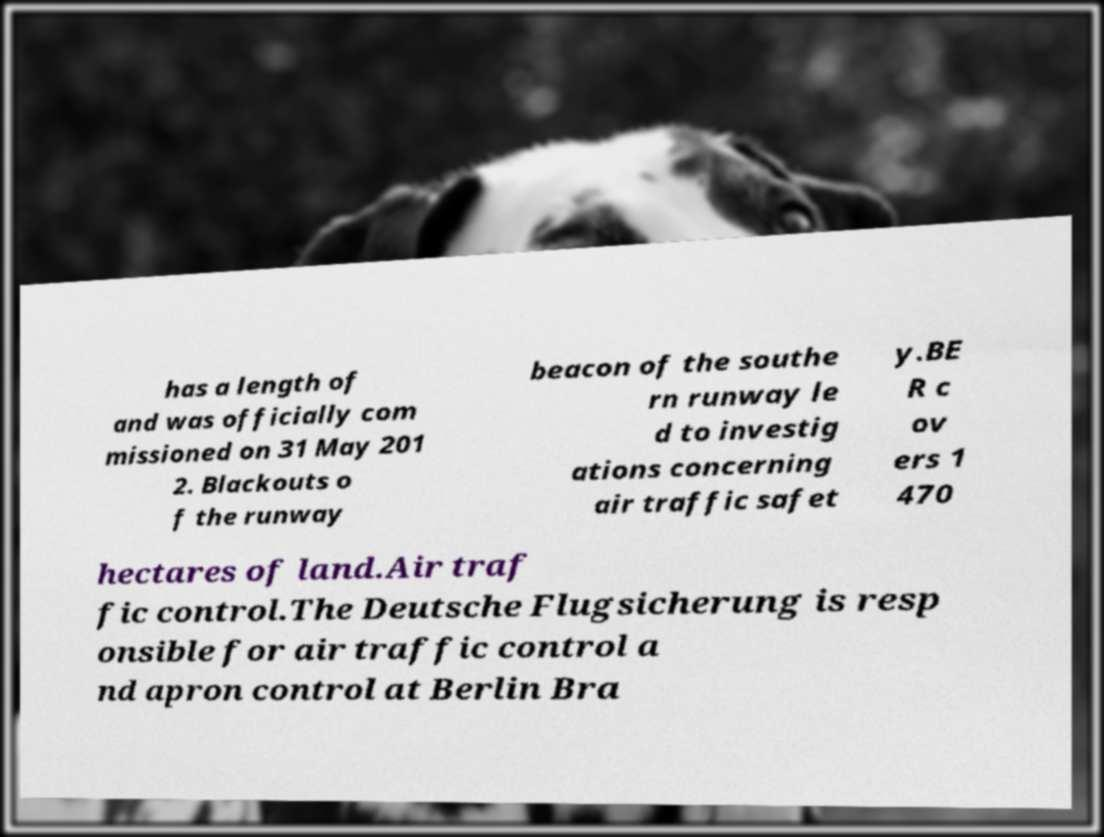For documentation purposes, I need the text within this image transcribed. Could you provide that? has a length of and was officially com missioned on 31 May 201 2. Blackouts o f the runway beacon of the southe rn runway le d to investig ations concerning air traffic safet y.BE R c ov ers 1 470 hectares of land.Air traf fic control.The Deutsche Flugsicherung is resp onsible for air traffic control a nd apron control at Berlin Bra 